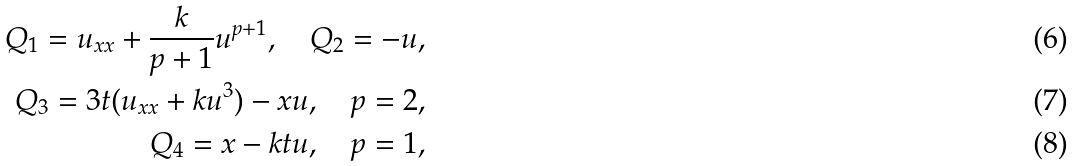Convert formula to latex. <formula><loc_0><loc_0><loc_500><loc_500>Q _ { 1 } = u _ { x x } + \frac { k } { p + 1 } u ^ { p + 1 } , \quad Q _ { 2 } = - u , \\ Q _ { 3 } = 3 t ( u _ { x x } + k u ^ { 3 } ) - x u , \quad p = 2 , \\ Q _ { 4 } = x - k t u , \quad p = 1 ,</formula> 